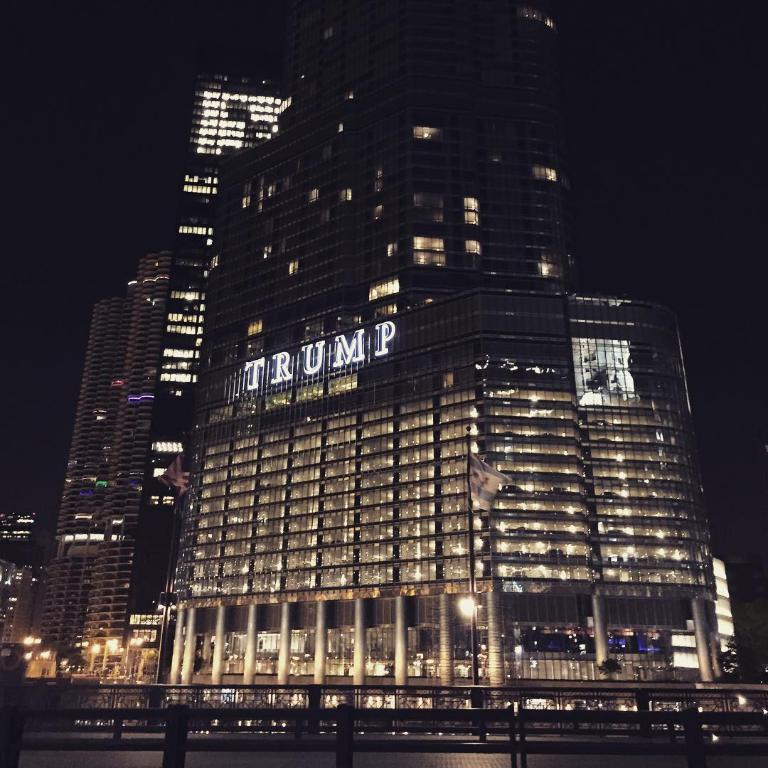Provide a one-sentence caption for the provided image. A well lit building with a Trump sign at the top. 